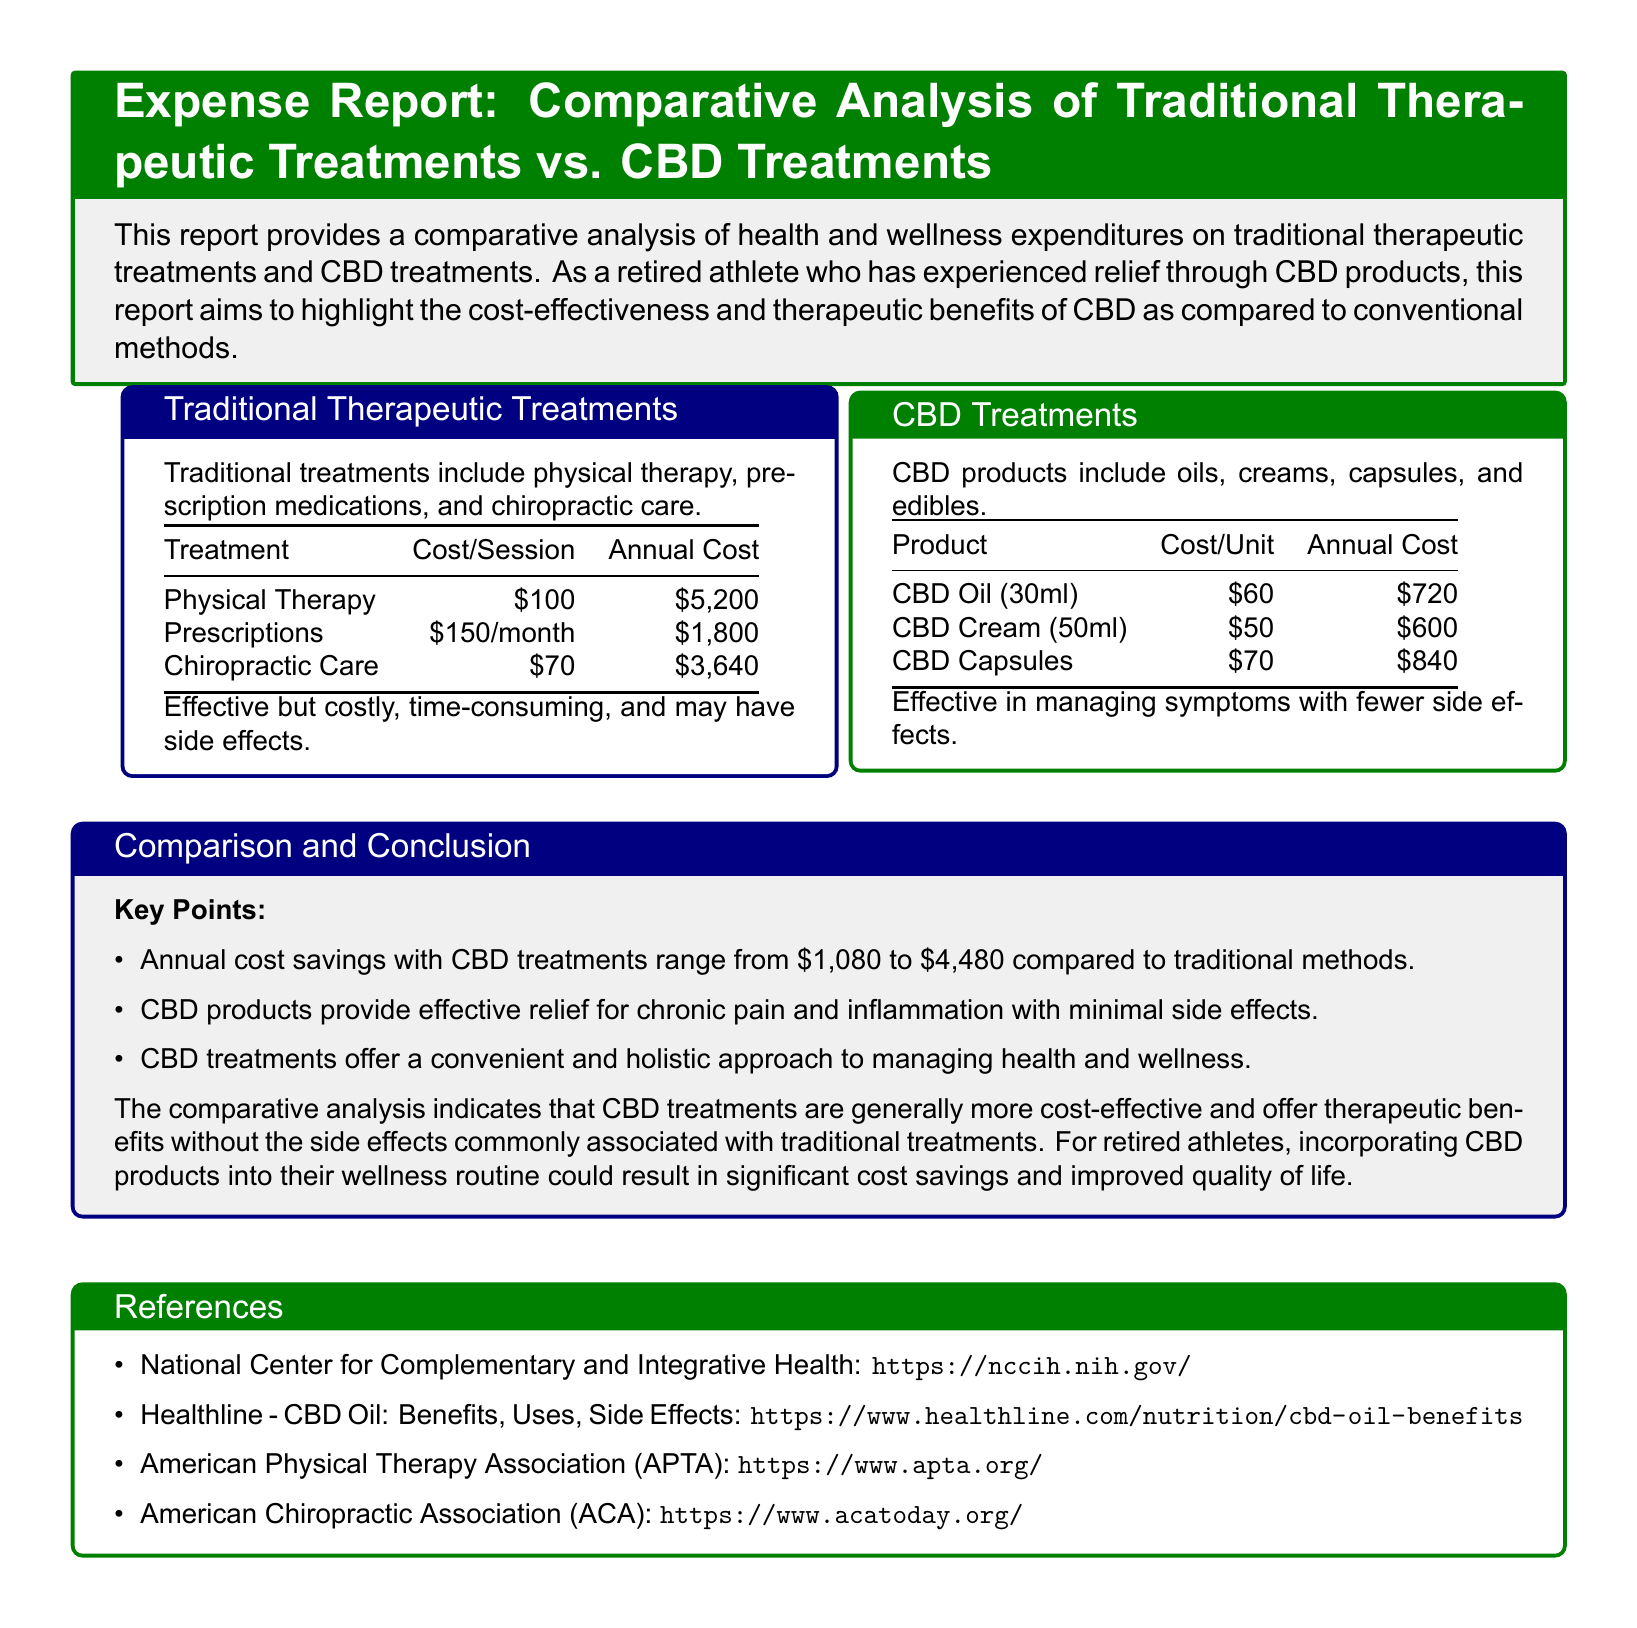What is the cost per session for physical therapy? The cost per session for physical therapy is listed in the document as $100.
Answer: $100 What is the annual cost of CBD Oil? The annual cost of CBD Oil (30ml) is specifically mentioned as $720 in the document.
Answer: $720 How much can one save annually by using CBD treatments compared to traditional methods? The document indicates that annual cost savings with CBD treatments range from $1,080 to $4,480 compared to traditional methods.
Answer: $1,080 to $4,480 What is the cost of CBD Cream? CBD Cream (50ml) is listed in the report with a cost of $50.
Answer: $50 What treatment has the lowest annual cost? The annual cost for CBD Cream is mentioned as $600, which is lower than all traditional treatments.
Answer: $600 Which treatment is effective in managing chronic pain with fewer side effects? The document claims that CBD products provide effective relief for chronic pain with minimal side effects.
Answer: CBD products What is the annual cost of chiropractic care? The document states that the annual cost of chiropractic care is $3,640.
Answer: $3,640 How many types of CBD products are mentioned? The document refers to four types of CBD products: oils, creams, capsules, and edibles.
Answer: Four types What color is used to frame the CBD treatments section? The document specifies that the CBD treatments section is framed in green.
Answer: Green 